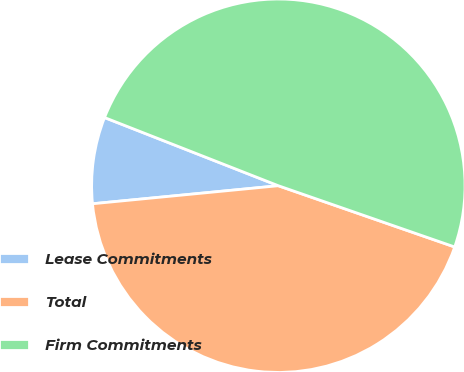Convert chart. <chart><loc_0><loc_0><loc_500><loc_500><pie_chart><fcel>Lease Commitments<fcel>Total<fcel>Firm Commitments<nl><fcel>7.49%<fcel>43.14%<fcel>49.37%<nl></chart> 